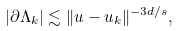Convert formula to latex. <formula><loc_0><loc_0><loc_500><loc_500>| { \partial \Lambda } _ { k } | \lesssim \| u - u _ { k } \| ^ { - 3 d / s } ,</formula> 